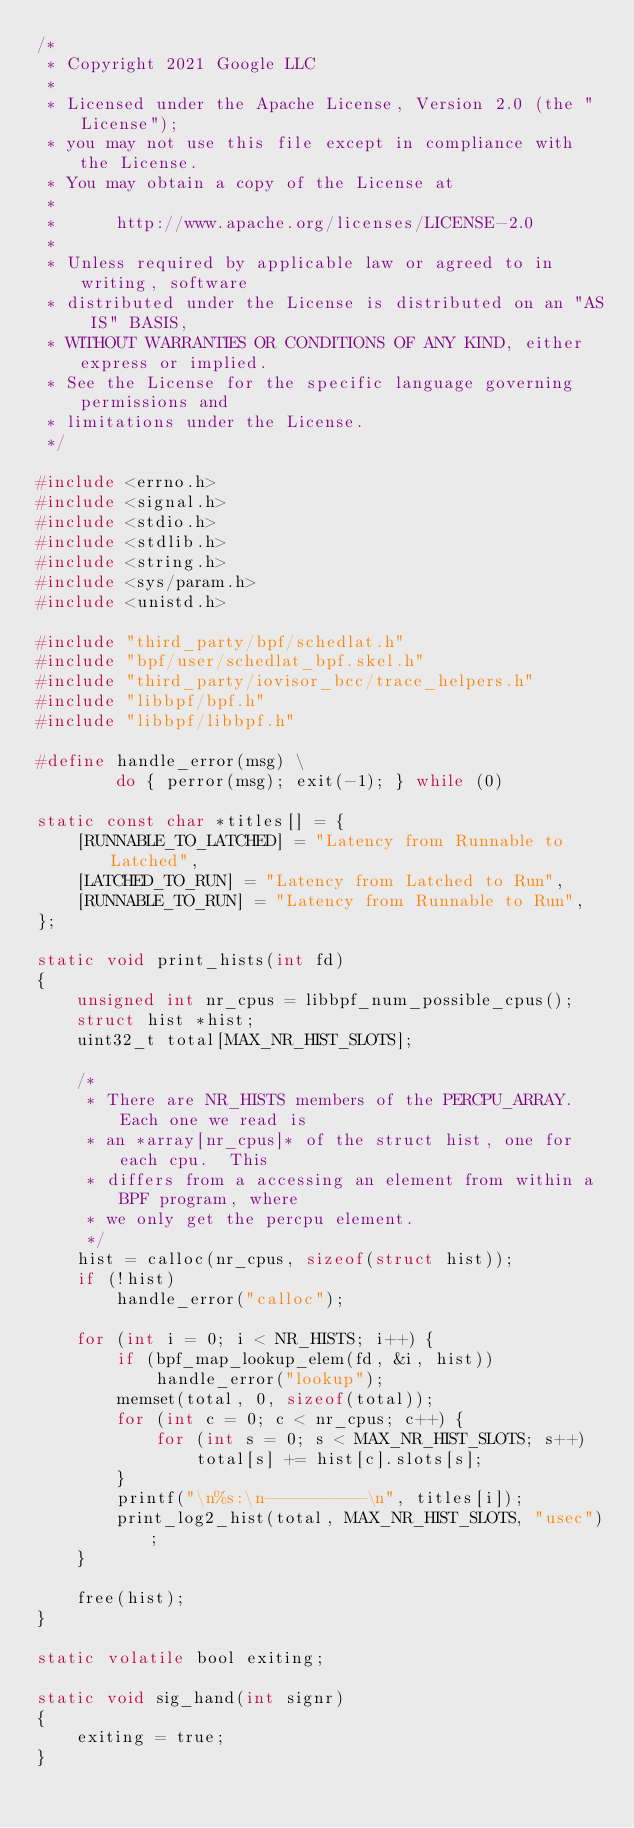<code> <loc_0><loc_0><loc_500><loc_500><_C_>/*
 * Copyright 2021 Google LLC
 *
 * Licensed under the Apache License, Version 2.0 (the "License");
 * you may not use this file except in compliance with the License.
 * You may obtain a copy of the License at
 *
 *      http://www.apache.org/licenses/LICENSE-2.0
 *
 * Unless required by applicable law or agreed to in writing, software
 * distributed under the License is distributed on an "AS IS" BASIS,
 * WITHOUT WARRANTIES OR CONDITIONS OF ANY KIND, either express or implied.
 * See the License for the specific language governing permissions and
 * limitations under the License.
 */

#include <errno.h>
#include <signal.h>
#include <stdio.h>
#include <stdlib.h>
#include <string.h>
#include <sys/param.h>
#include <unistd.h>

#include "third_party/bpf/schedlat.h"
#include "bpf/user/schedlat_bpf.skel.h"
#include "third_party/iovisor_bcc/trace_helpers.h"
#include "libbpf/bpf.h"
#include "libbpf/libbpf.h"

#define handle_error(msg) \
        do { perror(msg); exit(-1); } while (0)

static const char *titles[] = {
	[RUNNABLE_TO_LATCHED] = "Latency from Runnable to Latched",
	[LATCHED_TO_RUN] = "Latency from Latched to Run",
	[RUNNABLE_TO_RUN] = "Latency from Runnable to Run",
};

static void print_hists(int fd)
{
	unsigned int nr_cpus = libbpf_num_possible_cpus();
	struct hist *hist;
	uint32_t total[MAX_NR_HIST_SLOTS];

	/*
	 * There are NR_HISTS members of the PERCPU_ARRAY.  Each one we read is
	 * an *array[nr_cpus]* of the struct hist, one for each cpu.  This
	 * differs from a accessing an element from within a BPF program, where
	 * we only get the percpu element.
	 */
	hist = calloc(nr_cpus, sizeof(struct hist));
	if (!hist)
		handle_error("calloc");

	for (int i = 0; i < NR_HISTS; i++) {
		if (bpf_map_lookup_elem(fd, &i, hist))
			handle_error("lookup");
		memset(total, 0, sizeof(total));
		for (int c = 0; c < nr_cpus; c++) {
			for (int s = 0; s < MAX_NR_HIST_SLOTS; s++)
				total[s] += hist[c].slots[s];
		}
		printf("\n%s:\n----------\n", titles[i]);
		print_log2_hist(total, MAX_NR_HIST_SLOTS, "usec");
	}

	free(hist);
}

static volatile bool exiting;

static void sig_hand(int signr)
{
	exiting = true;
}
</code> 